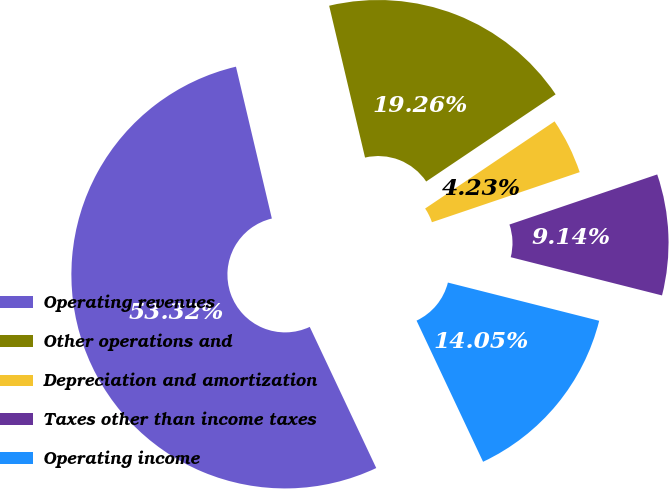<chart> <loc_0><loc_0><loc_500><loc_500><pie_chart><fcel>Operating revenues<fcel>Other operations and<fcel>Depreciation and amortization<fcel>Taxes other than income taxes<fcel>Operating income<nl><fcel>53.31%<fcel>19.26%<fcel>4.23%<fcel>9.14%<fcel>14.05%<nl></chart> 